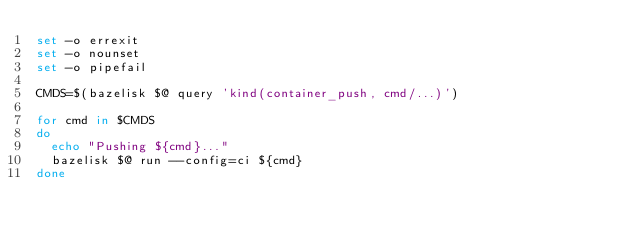Convert code to text. <code><loc_0><loc_0><loc_500><loc_500><_Bash_>set -o errexit
set -o nounset
set -o pipefail

CMDS=$(bazelisk $@ query 'kind(container_push, cmd/...)')

for cmd in $CMDS
do
  echo "Pushing ${cmd}..."
  bazelisk $@ run --config=ci ${cmd}
done
</code> 